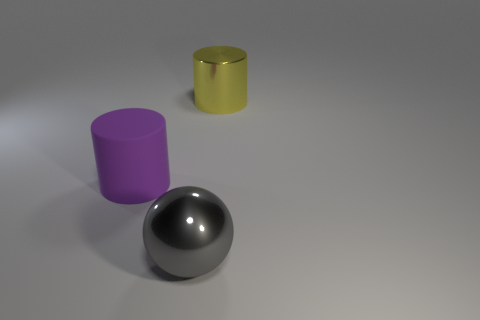Add 2 large purple rubber cylinders. How many objects exist? 5 Subtract all purple cylinders. How many cylinders are left? 1 Subtract all balls. How many objects are left? 2 Subtract 1 spheres. How many spheres are left? 0 Add 1 purple matte cylinders. How many purple matte cylinders exist? 2 Subtract 0 green cylinders. How many objects are left? 3 Subtract all yellow spheres. Subtract all blue blocks. How many spheres are left? 1 Subtract all shiny cylinders. Subtract all yellow metal things. How many objects are left? 1 Add 1 purple things. How many purple things are left? 2 